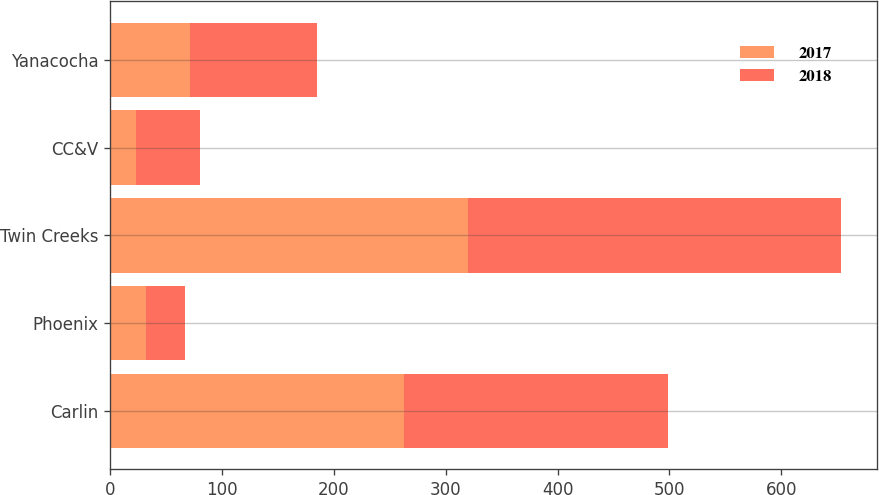Convert chart. <chart><loc_0><loc_0><loc_500><loc_500><stacked_bar_chart><ecel><fcel>Carlin<fcel>Phoenix<fcel>Twin Creeks<fcel>CC&V<fcel>Yanacocha<nl><fcel>2017<fcel>263<fcel>32<fcel>320<fcel>23<fcel>71<nl><fcel>2018<fcel>236<fcel>35<fcel>333<fcel>57<fcel>114<nl></chart> 